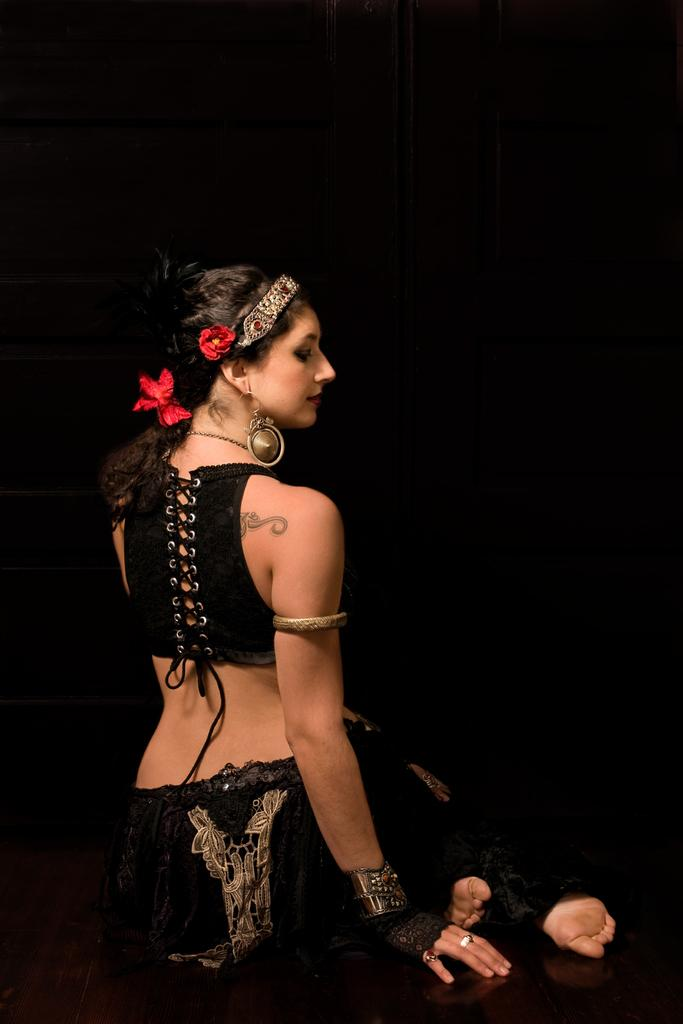Who is present in the image? There is a woman in the image. What is the woman doing in the image? The woman is sitting on the floor. What color is the background of the image? The background of the image is black. What type of linen is being used to play the record in the image? There is no linen or record present in the image. What is the woman doing on her back in the image? The woman is sitting on the floor, not lying on her back, in the image. 